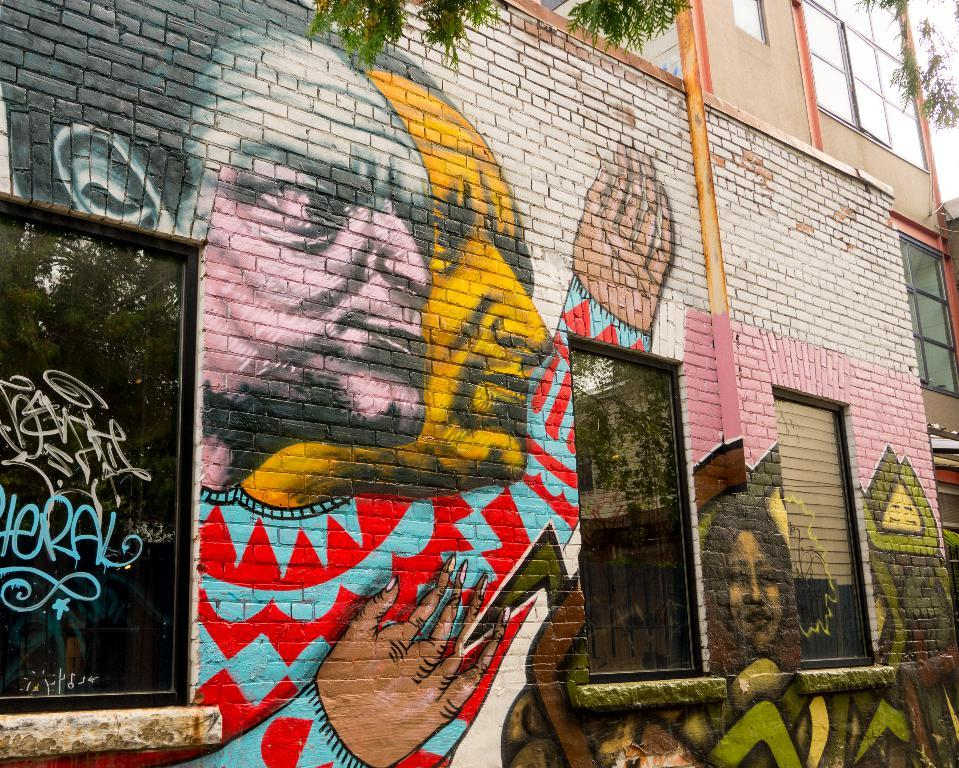What is depicted on the building in the image? There is a painting on a building in the image. What feature of the building is mentioned in the facts? The building has windows. What type of natural element can be seen at the top of the image? Trees are visible at the top of the image. What book is the person reading while walking in the image? There is no person reading a book or walking in the image; it only features a painting on a building and trees at the top. 